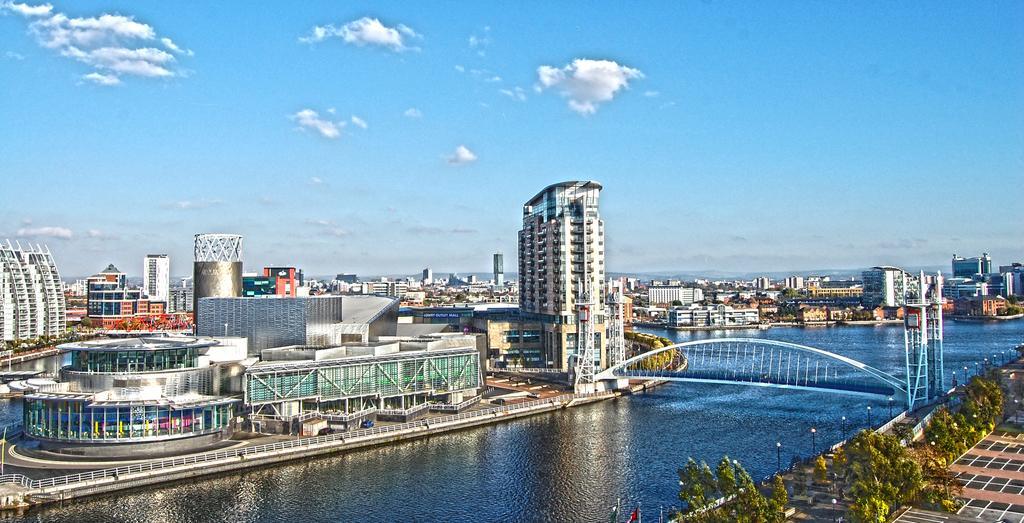In one or two sentences, can you explain what this image depicts? In this image we can see the aerial view of the city. There are buildings in the middle. At the bottom there is a lake. On the lake there is a bridge. On the right side there are trees and lights beside it. At the top there is sky. 